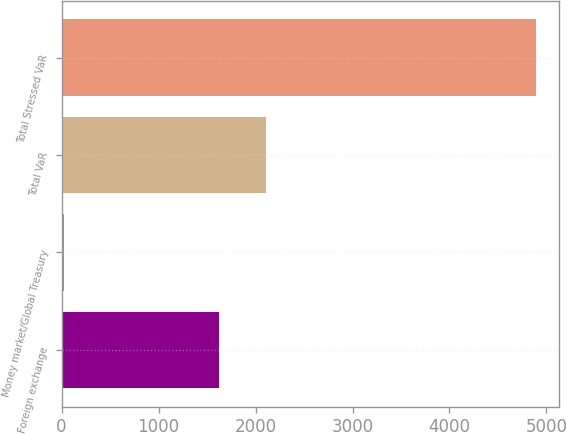Convert chart to OTSL. <chart><loc_0><loc_0><loc_500><loc_500><bar_chart><fcel>Foreign exchange<fcel>Money market/Global Treasury<fcel>Total VaR<fcel>Total Stressed VaR<nl><fcel>1626<fcel>24<fcel>2112.5<fcel>4889<nl></chart> 